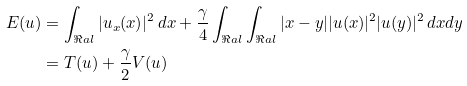<formula> <loc_0><loc_0><loc_500><loc_500>E ( u ) & = \int _ { \Re a l } | u _ { x } ( x ) | ^ { 2 } \, d x + \frac { \gamma } { 4 } \int _ { \Re a l } \int _ { \Re a l } | x - y | | u ( x ) | ^ { 2 } | u ( y ) | ^ { 2 } \, d x d y \\ & = T ( u ) + \frac { \gamma } { 2 } V ( u ) \\</formula> 